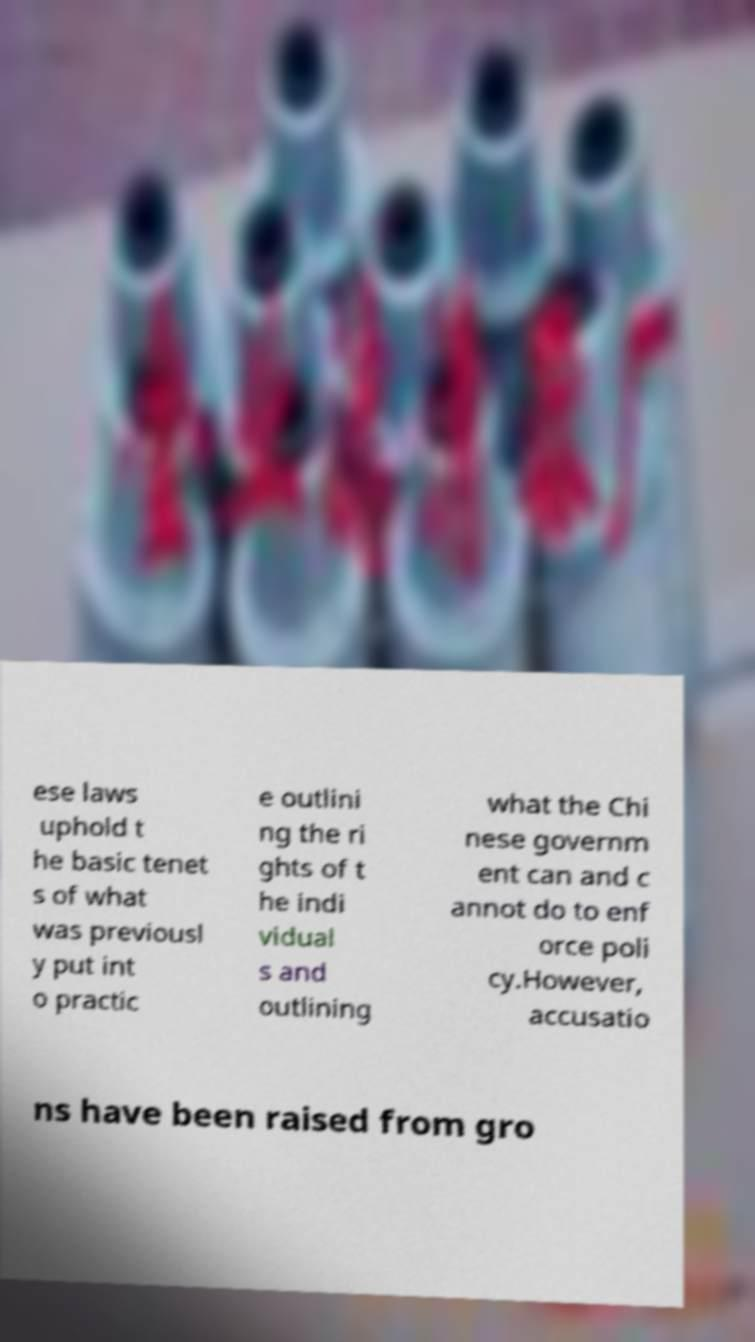Can you accurately transcribe the text from the provided image for me? ese laws uphold t he basic tenet s of what was previousl y put int o practic e outlini ng the ri ghts of t he indi vidual s and outlining what the Chi nese governm ent can and c annot do to enf orce poli cy.However, accusatio ns have been raised from gro 